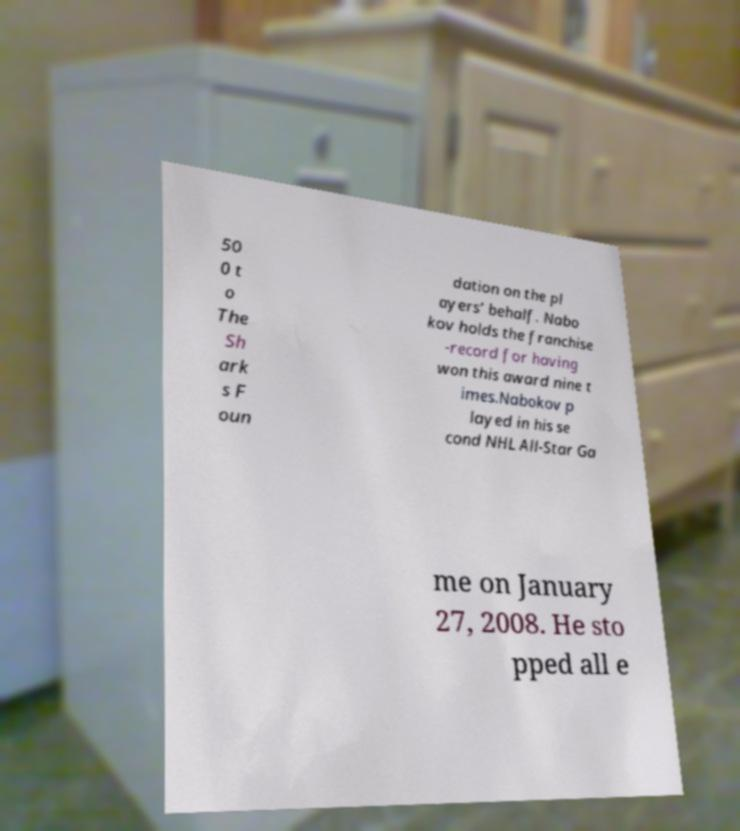For documentation purposes, I need the text within this image transcribed. Could you provide that? 50 0 t o The Sh ark s F oun dation on the pl ayers’ behalf. Nabo kov holds the franchise -record for having won this award nine t imes.Nabokov p layed in his se cond NHL All-Star Ga me on January 27, 2008. He sto pped all e 